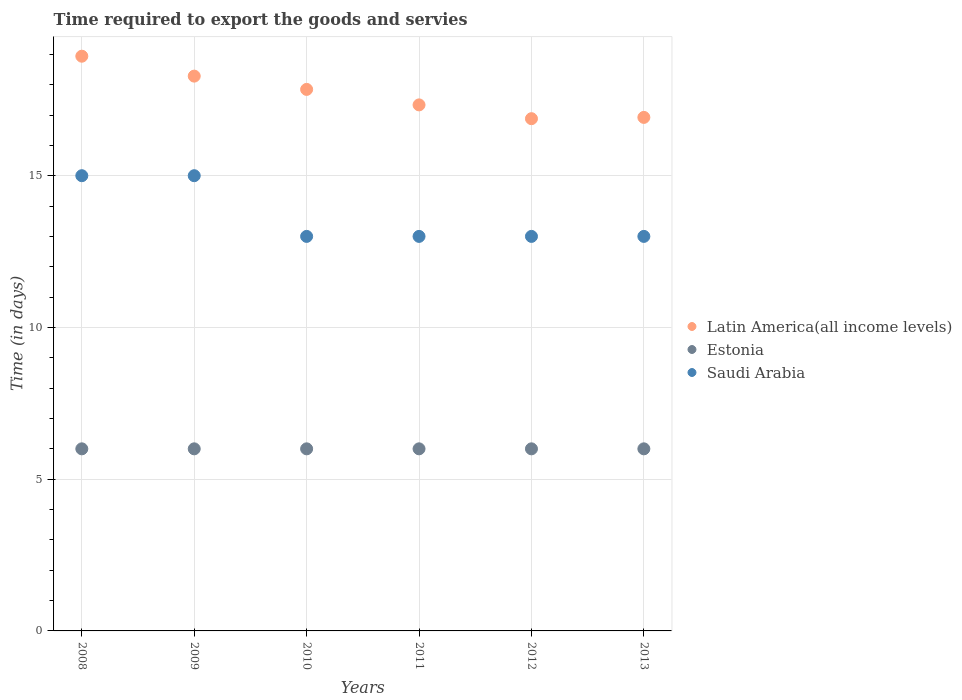How many different coloured dotlines are there?
Offer a terse response. 3. Is the number of dotlines equal to the number of legend labels?
Give a very brief answer. Yes. What is the number of days required to export the goods and services in Saudi Arabia in 2013?
Ensure brevity in your answer.  13. Across all years, what is the maximum number of days required to export the goods and services in Latin America(all income levels)?
Provide a succinct answer. 18.94. Across all years, what is the minimum number of days required to export the goods and services in Latin America(all income levels)?
Keep it short and to the point. 16.88. In which year was the number of days required to export the goods and services in Latin America(all income levels) maximum?
Ensure brevity in your answer.  2008. In which year was the number of days required to export the goods and services in Estonia minimum?
Your answer should be very brief. 2008. What is the total number of days required to export the goods and services in Latin America(all income levels) in the graph?
Give a very brief answer. 106.2. What is the difference between the number of days required to export the goods and services in Estonia in 2008 and that in 2011?
Your response must be concise. 0. What is the difference between the number of days required to export the goods and services in Estonia in 2011 and the number of days required to export the goods and services in Latin America(all income levels) in 2013?
Offer a terse response. -10.92. What is the average number of days required to export the goods and services in Estonia per year?
Provide a succinct answer. 6. In the year 2010, what is the difference between the number of days required to export the goods and services in Estonia and number of days required to export the goods and services in Latin America(all income levels)?
Keep it short and to the point. -11.84. In how many years, is the number of days required to export the goods and services in Saudi Arabia greater than 6 days?
Keep it short and to the point. 6. What is the ratio of the number of days required to export the goods and services in Latin America(all income levels) in 2010 to that in 2012?
Your answer should be compact. 1.06. What is the difference between the highest and the second highest number of days required to export the goods and services in Latin America(all income levels)?
Keep it short and to the point. 0.66. What is the difference between the highest and the lowest number of days required to export the goods and services in Latin America(all income levels)?
Provide a succinct answer. 2.06. Is the number of days required to export the goods and services in Latin America(all income levels) strictly less than the number of days required to export the goods and services in Saudi Arabia over the years?
Offer a terse response. No. How many years are there in the graph?
Give a very brief answer. 6. What is the difference between two consecutive major ticks on the Y-axis?
Offer a terse response. 5. Are the values on the major ticks of Y-axis written in scientific E-notation?
Provide a short and direct response. No. Does the graph contain any zero values?
Make the answer very short. No. Does the graph contain grids?
Give a very brief answer. Yes. How many legend labels are there?
Your response must be concise. 3. What is the title of the graph?
Make the answer very short. Time required to export the goods and servies. Does "Belize" appear as one of the legend labels in the graph?
Your response must be concise. No. What is the label or title of the X-axis?
Ensure brevity in your answer.  Years. What is the label or title of the Y-axis?
Make the answer very short. Time (in days). What is the Time (in days) in Latin America(all income levels) in 2008?
Give a very brief answer. 18.94. What is the Time (in days) of Estonia in 2008?
Ensure brevity in your answer.  6. What is the Time (in days) of Latin America(all income levels) in 2009?
Your answer should be compact. 18.28. What is the Time (in days) of Latin America(all income levels) in 2010?
Provide a succinct answer. 17.84. What is the Time (in days) of Saudi Arabia in 2010?
Ensure brevity in your answer.  13. What is the Time (in days) in Latin America(all income levels) in 2011?
Make the answer very short. 17.33. What is the Time (in days) in Estonia in 2011?
Provide a succinct answer. 6. What is the Time (in days) in Saudi Arabia in 2011?
Make the answer very short. 13. What is the Time (in days) in Latin America(all income levels) in 2012?
Make the answer very short. 16.88. What is the Time (in days) in Latin America(all income levels) in 2013?
Your answer should be very brief. 16.92. Across all years, what is the maximum Time (in days) of Latin America(all income levels)?
Your answer should be very brief. 18.94. Across all years, what is the maximum Time (in days) of Saudi Arabia?
Give a very brief answer. 15. Across all years, what is the minimum Time (in days) in Latin America(all income levels)?
Make the answer very short. 16.88. Across all years, what is the minimum Time (in days) in Estonia?
Offer a very short reply. 6. Across all years, what is the minimum Time (in days) in Saudi Arabia?
Provide a succinct answer. 13. What is the total Time (in days) in Latin America(all income levels) in the graph?
Offer a terse response. 106.2. What is the total Time (in days) of Estonia in the graph?
Offer a terse response. 36. What is the total Time (in days) in Saudi Arabia in the graph?
Give a very brief answer. 82. What is the difference between the Time (in days) in Latin America(all income levels) in 2008 and that in 2009?
Your response must be concise. 0.66. What is the difference between the Time (in days) of Latin America(all income levels) in 2008 and that in 2010?
Offer a very short reply. 1.09. What is the difference between the Time (in days) of Latin America(all income levels) in 2008 and that in 2011?
Your answer should be compact. 1.6. What is the difference between the Time (in days) in Estonia in 2008 and that in 2011?
Make the answer very short. 0. What is the difference between the Time (in days) of Saudi Arabia in 2008 and that in 2011?
Ensure brevity in your answer.  2. What is the difference between the Time (in days) of Latin America(all income levels) in 2008 and that in 2012?
Keep it short and to the point. 2.06. What is the difference between the Time (in days) of Saudi Arabia in 2008 and that in 2012?
Offer a terse response. 2. What is the difference between the Time (in days) in Latin America(all income levels) in 2008 and that in 2013?
Your response must be concise. 2.02. What is the difference between the Time (in days) of Estonia in 2008 and that in 2013?
Offer a very short reply. 0. What is the difference between the Time (in days) in Latin America(all income levels) in 2009 and that in 2010?
Offer a very short reply. 0.44. What is the difference between the Time (in days) of Saudi Arabia in 2009 and that in 2010?
Your response must be concise. 2. What is the difference between the Time (in days) in Latin America(all income levels) in 2009 and that in 2011?
Provide a succinct answer. 0.95. What is the difference between the Time (in days) in Estonia in 2009 and that in 2011?
Offer a very short reply. 0. What is the difference between the Time (in days) in Saudi Arabia in 2009 and that in 2011?
Provide a short and direct response. 2. What is the difference between the Time (in days) in Latin America(all income levels) in 2009 and that in 2012?
Your answer should be compact. 1.4. What is the difference between the Time (in days) in Saudi Arabia in 2009 and that in 2012?
Keep it short and to the point. 2. What is the difference between the Time (in days) in Latin America(all income levels) in 2009 and that in 2013?
Keep it short and to the point. 1.36. What is the difference between the Time (in days) of Saudi Arabia in 2009 and that in 2013?
Your response must be concise. 2. What is the difference between the Time (in days) in Latin America(all income levels) in 2010 and that in 2011?
Keep it short and to the point. 0.51. What is the difference between the Time (in days) of Estonia in 2010 and that in 2011?
Provide a succinct answer. 0. What is the difference between the Time (in days) of Estonia in 2010 and that in 2012?
Your response must be concise. 0. What is the difference between the Time (in days) of Saudi Arabia in 2010 and that in 2012?
Offer a very short reply. 0. What is the difference between the Time (in days) of Latin America(all income levels) in 2010 and that in 2013?
Your response must be concise. 0.92. What is the difference between the Time (in days) of Saudi Arabia in 2010 and that in 2013?
Provide a succinct answer. 0. What is the difference between the Time (in days) in Latin America(all income levels) in 2011 and that in 2012?
Your response must be concise. 0.45. What is the difference between the Time (in days) of Latin America(all income levels) in 2011 and that in 2013?
Make the answer very short. 0.41. What is the difference between the Time (in days) of Estonia in 2011 and that in 2013?
Your answer should be very brief. 0. What is the difference between the Time (in days) of Latin America(all income levels) in 2012 and that in 2013?
Ensure brevity in your answer.  -0.04. What is the difference between the Time (in days) of Saudi Arabia in 2012 and that in 2013?
Offer a terse response. 0. What is the difference between the Time (in days) in Latin America(all income levels) in 2008 and the Time (in days) in Estonia in 2009?
Ensure brevity in your answer.  12.94. What is the difference between the Time (in days) of Latin America(all income levels) in 2008 and the Time (in days) of Saudi Arabia in 2009?
Ensure brevity in your answer.  3.94. What is the difference between the Time (in days) of Latin America(all income levels) in 2008 and the Time (in days) of Estonia in 2010?
Your response must be concise. 12.94. What is the difference between the Time (in days) of Latin America(all income levels) in 2008 and the Time (in days) of Saudi Arabia in 2010?
Your answer should be very brief. 5.94. What is the difference between the Time (in days) of Latin America(all income levels) in 2008 and the Time (in days) of Estonia in 2011?
Offer a terse response. 12.94. What is the difference between the Time (in days) in Latin America(all income levels) in 2008 and the Time (in days) in Saudi Arabia in 2011?
Ensure brevity in your answer.  5.94. What is the difference between the Time (in days) in Estonia in 2008 and the Time (in days) in Saudi Arabia in 2011?
Provide a succinct answer. -7. What is the difference between the Time (in days) in Latin America(all income levels) in 2008 and the Time (in days) in Estonia in 2012?
Your response must be concise. 12.94. What is the difference between the Time (in days) of Latin America(all income levels) in 2008 and the Time (in days) of Saudi Arabia in 2012?
Keep it short and to the point. 5.94. What is the difference between the Time (in days) in Estonia in 2008 and the Time (in days) in Saudi Arabia in 2012?
Provide a succinct answer. -7. What is the difference between the Time (in days) of Latin America(all income levels) in 2008 and the Time (in days) of Estonia in 2013?
Provide a succinct answer. 12.94. What is the difference between the Time (in days) in Latin America(all income levels) in 2008 and the Time (in days) in Saudi Arabia in 2013?
Your response must be concise. 5.94. What is the difference between the Time (in days) in Estonia in 2008 and the Time (in days) in Saudi Arabia in 2013?
Give a very brief answer. -7. What is the difference between the Time (in days) in Latin America(all income levels) in 2009 and the Time (in days) in Estonia in 2010?
Your response must be concise. 12.28. What is the difference between the Time (in days) of Latin America(all income levels) in 2009 and the Time (in days) of Saudi Arabia in 2010?
Ensure brevity in your answer.  5.28. What is the difference between the Time (in days) in Latin America(all income levels) in 2009 and the Time (in days) in Estonia in 2011?
Provide a short and direct response. 12.28. What is the difference between the Time (in days) in Latin America(all income levels) in 2009 and the Time (in days) in Saudi Arabia in 2011?
Offer a very short reply. 5.28. What is the difference between the Time (in days) in Estonia in 2009 and the Time (in days) in Saudi Arabia in 2011?
Your response must be concise. -7. What is the difference between the Time (in days) in Latin America(all income levels) in 2009 and the Time (in days) in Estonia in 2012?
Ensure brevity in your answer.  12.28. What is the difference between the Time (in days) of Latin America(all income levels) in 2009 and the Time (in days) of Saudi Arabia in 2012?
Provide a short and direct response. 5.28. What is the difference between the Time (in days) in Latin America(all income levels) in 2009 and the Time (in days) in Estonia in 2013?
Ensure brevity in your answer.  12.28. What is the difference between the Time (in days) in Latin America(all income levels) in 2009 and the Time (in days) in Saudi Arabia in 2013?
Make the answer very short. 5.28. What is the difference between the Time (in days) of Estonia in 2009 and the Time (in days) of Saudi Arabia in 2013?
Provide a short and direct response. -7. What is the difference between the Time (in days) of Latin America(all income levels) in 2010 and the Time (in days) of Estonia in 2011?
Ensure brevity in your answer.  11.84. What is the difference between the Time (in days) of Latin America(all income levels) in 2010 and the Time (in days) of Saudi Arabia in 2011?
Provide a succinct answer. 4.84. What is the difference between the Time (in days) in Estonia in 2010 and the Time (in days) in Saudi Arabia in 2011?
Provide a short and direct response. -7. What is the difference between the Time (in days) in Latin America(all income levels) in 2010 and the Time (in days) in Estonia in 2012?
Your answer should be very brief. 11.84. What is the difference between the Time (in days) in Latin America(all income levels) in 2010 and the Time (in days) in Saudi Arabia in 2012?
Your answer should be very brief. 4.84. What is the difference between the Time (in days) in Estonia in 2010 and the Time (in days) in Saudi Arabia in 2012?
Provide a short and direct response. -7. What is the difference between the Time (in days) of Latin America(all income levels) in 2010 and the Time (in days) of Estonia in 2013?
Your answer should be compact. 11.84. What is the difference between the Time (in days) in Latin America(all income levels) in 2010 and the Time (in days) in Saudi Arabia in 2013?
Your answer should be compact. 4.84. What is the difference between the Time (in days) of Latin America(all income levels) in 2011 and the Time (in days) of Estonia in 2012?
Your answer should be compact. 11.33. What is the difference between the Time (in days) of Latin America(all income levels) in 2011 and the Time (in days) of Saudi Arabia in 2012?
Provide a succinct answer. 4.33. What is the difference between the Time (in days) of Estonia in 2011 and the Time (in days) of Saudi Arabia in 2012?
Give a very brief answer. -7. What is the difference between the Time (in days) of Latin America(all income levels) in 2011 and the Time (in days) of Estonia in 2013?
Keep it short and to the point. 11.33. What is the difference between the Time (in days) in Latin America(all income levels) in 2011 and the Time (in days) in Saudi Arabia in 2013?
Your answer should be compact. 4.33. What is the difference between the Time (in days) in Estonia in 2011 and the Time (in days) in Saudi Arabia in 2013?
Your answer should be very brief. -7. What is the difference between the Time (in days) in Latin America(all income levels) in 2012 and the Time (in days) in Estonia in 2013?
Offer a very short reply. 10.88. What is the difference between the Time (in days) in Latin America(all income levels) in 2012 and the Time (in days) in Saudi Arabia in 2013?
Your answer should be very brief. 3.88. What is the difference between the Time (in days) of Estonia in 2012 and the Time (in days) of Saudi Arabia in 2013?
Ensure brevity in your answer.  -7. What is the average Time (in days) of Latin America(all income levels) per year?
Offer a terse response. 17.7. What is the average Time (in days) of Estonia per year?
Provide a short and direct response. 6. What is the average Time (in days) of Saudi Arabia per year?
Your answer should be compact. 13.67. In the year 2008, what is the difference between the Time (in days) in Latin America(all income levels) and Time (in days) in Estonia?
Your response must be concise. 12.94. In the year 2008, what is the difference between the Time (in days) in Latin America(all income levels) and Time (in days) in Saudi Arabia?
Keep it short and to the point. 3.94. In the year 2009, what is the difference between the Time (in days) of Latin America(all income levels) and Time (in days) of Estonia?
Provide a short and direct response. 12.28. In the year 2009, what is the difference between the Time (in days) of Latin America(all income levels) and Time (in days) of Saudi Arabia?
Make the answer very short. 3.28. In the year 2010, what is the difference between the Time (in days) in Latin America(all income levels) and Time (in days) in Estonia?
Your answer should be very brief. 11.84. In the year 2010, what is the difference between the Time (in days) in Latin America(all income levels) and Time (in days) in Saudi Arabia?
Make the answer very short. 4.84. In the year 2010, what is the difference between the Time (in days) of Estonia and Time (in days) of Saudi Arabia?
Offer a very short reply. -7. In the year 2011, what is the difference between the Time (in days) in Latin America(all income levels) and Time (in days) in Estonia?
Your response must be concise. 11.33. In the year 2011, what is the difference between the Time (in days) of Latin America(all income levels) and Time (in days) of Saudi Arabia?
Offer a very short reply. 4.33. In the year 2012, what is the difference between the Time (in days) of Latin America(all income levels) and Time (in days) of Estonia?
Your answer should be very brief. 10.88. In the year 2012, what is the difference between the Time (in days) in Latin America(all income levels) and Time (in days) in Saudi Arabia?
Offer a very short reply. 3.88. In the year 2013, what is the difference between the Time (in days) of Latin America(all income levels) and Time (in days) of Estonia?
Offer a very short reply. 10.92. In the year 2013, what is the difference between the Time (in days) of Latin America(all income levels) and Time (in days) of Saudi Arabia?
Provide a succinct answer. 3.92. What is the ratio of the Time (in days) in Latin America(all income levels) in 2008 to that in 2009?
Ensure brevity in your answer.  1.04. What is the ratio of the Time (in days) in Estonia in 2008 to that in 2009?
Offer a terse response. 1. What is the ratio of the Time (in days) of Saudi Arabia in 2008 to that in 2009?
Make the answer very short. 1. What is the ratio of the Time (in days) of Latin America(all income levels) in 2008 to that in 2010?
Provide a short and direct response. 1.06. What is the ratio of the Time (in days) in Estonia in 2008 to that in 2010?
Your answer should be very brief. 1. What is the ratio of the Time (in days) in Saudi Arabia in 2008 to that in 2010?
Provide a short and direct response. 1.15. What is the ratio of the Time (in days) in Latin America(all income levels) in 2008 to that in 2011?
Your answer should be compact. 1.09. What is the ratio of the Time (in days) of Saudi Arabia in 2008 to that in 2011?
Make the answer very short. 1.15. What is the ratio of the Time (in days) in Latin America(all income levels) in 2008 to that in 2012?
Provide a short and direct response. 1.12. What is the ratio of the Time (in days) in Saudi Arabia in 2008 to that in 2012?
Your answer should be compact. 1.15. What is the ratio of the Time (in days) of Latin America(all income levels) in 2008 to that in 2013?
Keep it short and to the point. 1.12. What is the ratio of the Time (in days) in Estonia in 2008 to that in 2013?
Your response must be concise. 1. What is the ratio of the Time (in days) of Saudi Arabia in 2008 to that in 2013?
Keep it short and to the point. 1.15. What is the ratio of the Time (in days) of Latin America(all income levels) in 2009 to that in 2010?
Your answer should be compact. 1.02. What is the ratio of the Time (in days) in Saudi Arabia in 2009 to that in 2010?
Offer a terse response. 1.15. What is the ratio of the Time (in days) in Latin America(all income levels) in 2009 to that in 2011?
Make the answer very short. 1.05. What is the ratio of the Time (in days) in Saudi Arabia in 2009 to that in 2011?
Your response must be concise. 1.15. What is the ratio of the Time (in days) in Latin America(all income levels) in 2009 to that in 2012?
Ensure brevity in your answer.  1.08. What is the ratio of the Time (in days) of Saudi Arabia in 2009 to that in 2012?
Offer a terse response. 1.15. What is the ratio of the Time (in days) of Latin America(all income levels) in 2009 to that in 2013?
Provide a short and direct response. 1.08. What is the ratio of the Time (in days) in Estonia in 2009 to that in 2013?
Give a very brief answer. 1. What is the ratio of the Time (in days) of Saudi Arabia in 2009 to that in 2013?
Provide a short and direct response. 1.15. What is the ratio of the Time (in days) in Latin America(all income levels) in 2010 to that in 2011?
Ensure brevity in your answer.  1.03. What is the ratio of the Time (in days) of Latin America(all income levels) in 2010 to that in 2012?
Provide a short and direct response. 1.06. What is the ratio of the Time (in days) of Saudi Arabia in 2010 to that in 2012?
Ensure brevity in your answer.  1. What is the ratio of the Time (in days) of Latin America(all income levels) in 2010 to that in 2013?
Provide a succinct answer. 1.05. What is the ratio of the Time (in days) of Estonia in 2010 to that in 2013?
Make the answer very short. 1. What is the ratio of the Time (in days) of Saudi Arabia in 2010 to that in 2013?
Offer a terse response. 1. What is the ratio of the Time (in days) in Latin America(all income levels) in 2011 to that in 2012?
Your answer should be compact. 1.03. What is the ratio of the Time (in days) in Latin America(all income levels) in 2011 to that in 2013?
Keep it short and to the point. 1.02. What is the ratio of the Time (in days) of Saudi Arabia in 2011 to that in 2013?
Provide a short and direct response. 1. What is the ratio of the Time (in days) in Latin America(all income levels) in 2012 to that in 2013?
Ensure brevity in your answer.  1. What is the difference between the highest and the second highest Time (in days) in Latin America(all income levels)?
Ensure brevity in your answer.  0.66. What is the difference between the highest and the second highest Time (in days) in Estonia?
Provide a short and direct response. 0. What is the difference between the highest and the second highest Time (in days) in Saudi Arabia?
Offer a very short reply. 0. What is the difference between the highest and the lowest Time (in days) of Latin America(all income levels)?
Ensure brevity in your answer.  2.06. 